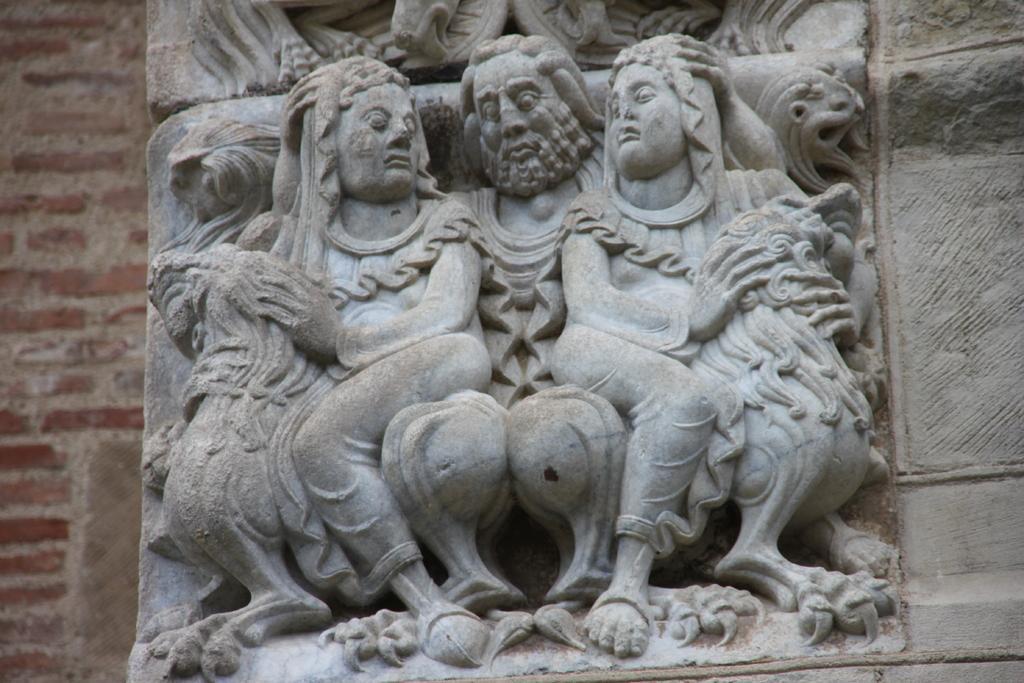In one or two sentences, can you explain what this image depicts? In this picture I can observe carvings on the stone. The stone is in grey color. These are the carvings of humans. In the background there is a wall. 